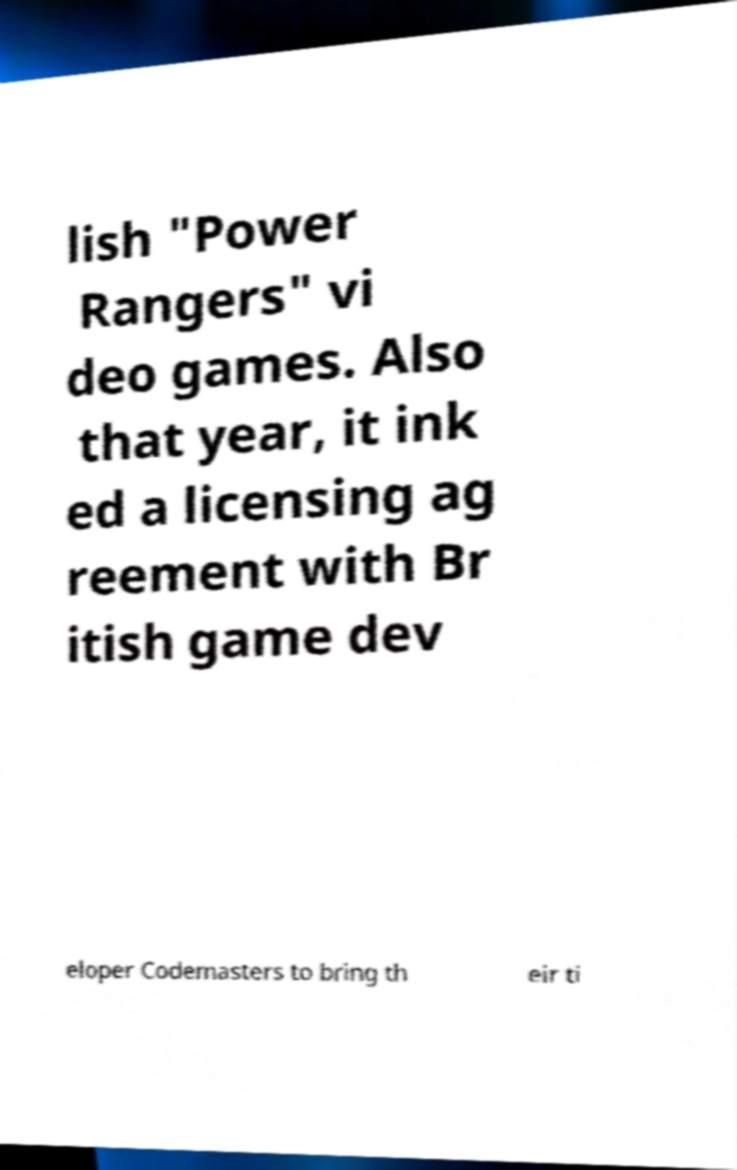Could you assist in decoding the text presented in this image and type it out clearly? lish "Power Rangers" vi deo games. Also that year, it ink ed a licensing ag reement with Br itish game dev eloper Codemasters to bring th eir ti 